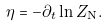<formula> <loc_0><loc_0><loc_500><loc_500>\eta = - \partial _ { t } \ln Z _ { \text {N} } .</formula> 